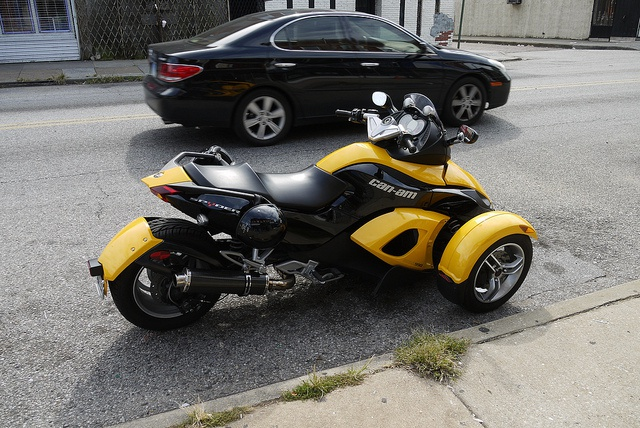Describe the objects in this image and their specific colors. I can see motorcycle in black, gray, darkgray, and lightgray tones and car in black, gray, and darkblue tones in this image. 